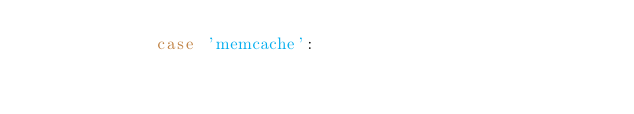Convert code to text. <code><loc_0><loc_0><loc_500><loc_500><_PHP_>            case 'memcache':</code> 